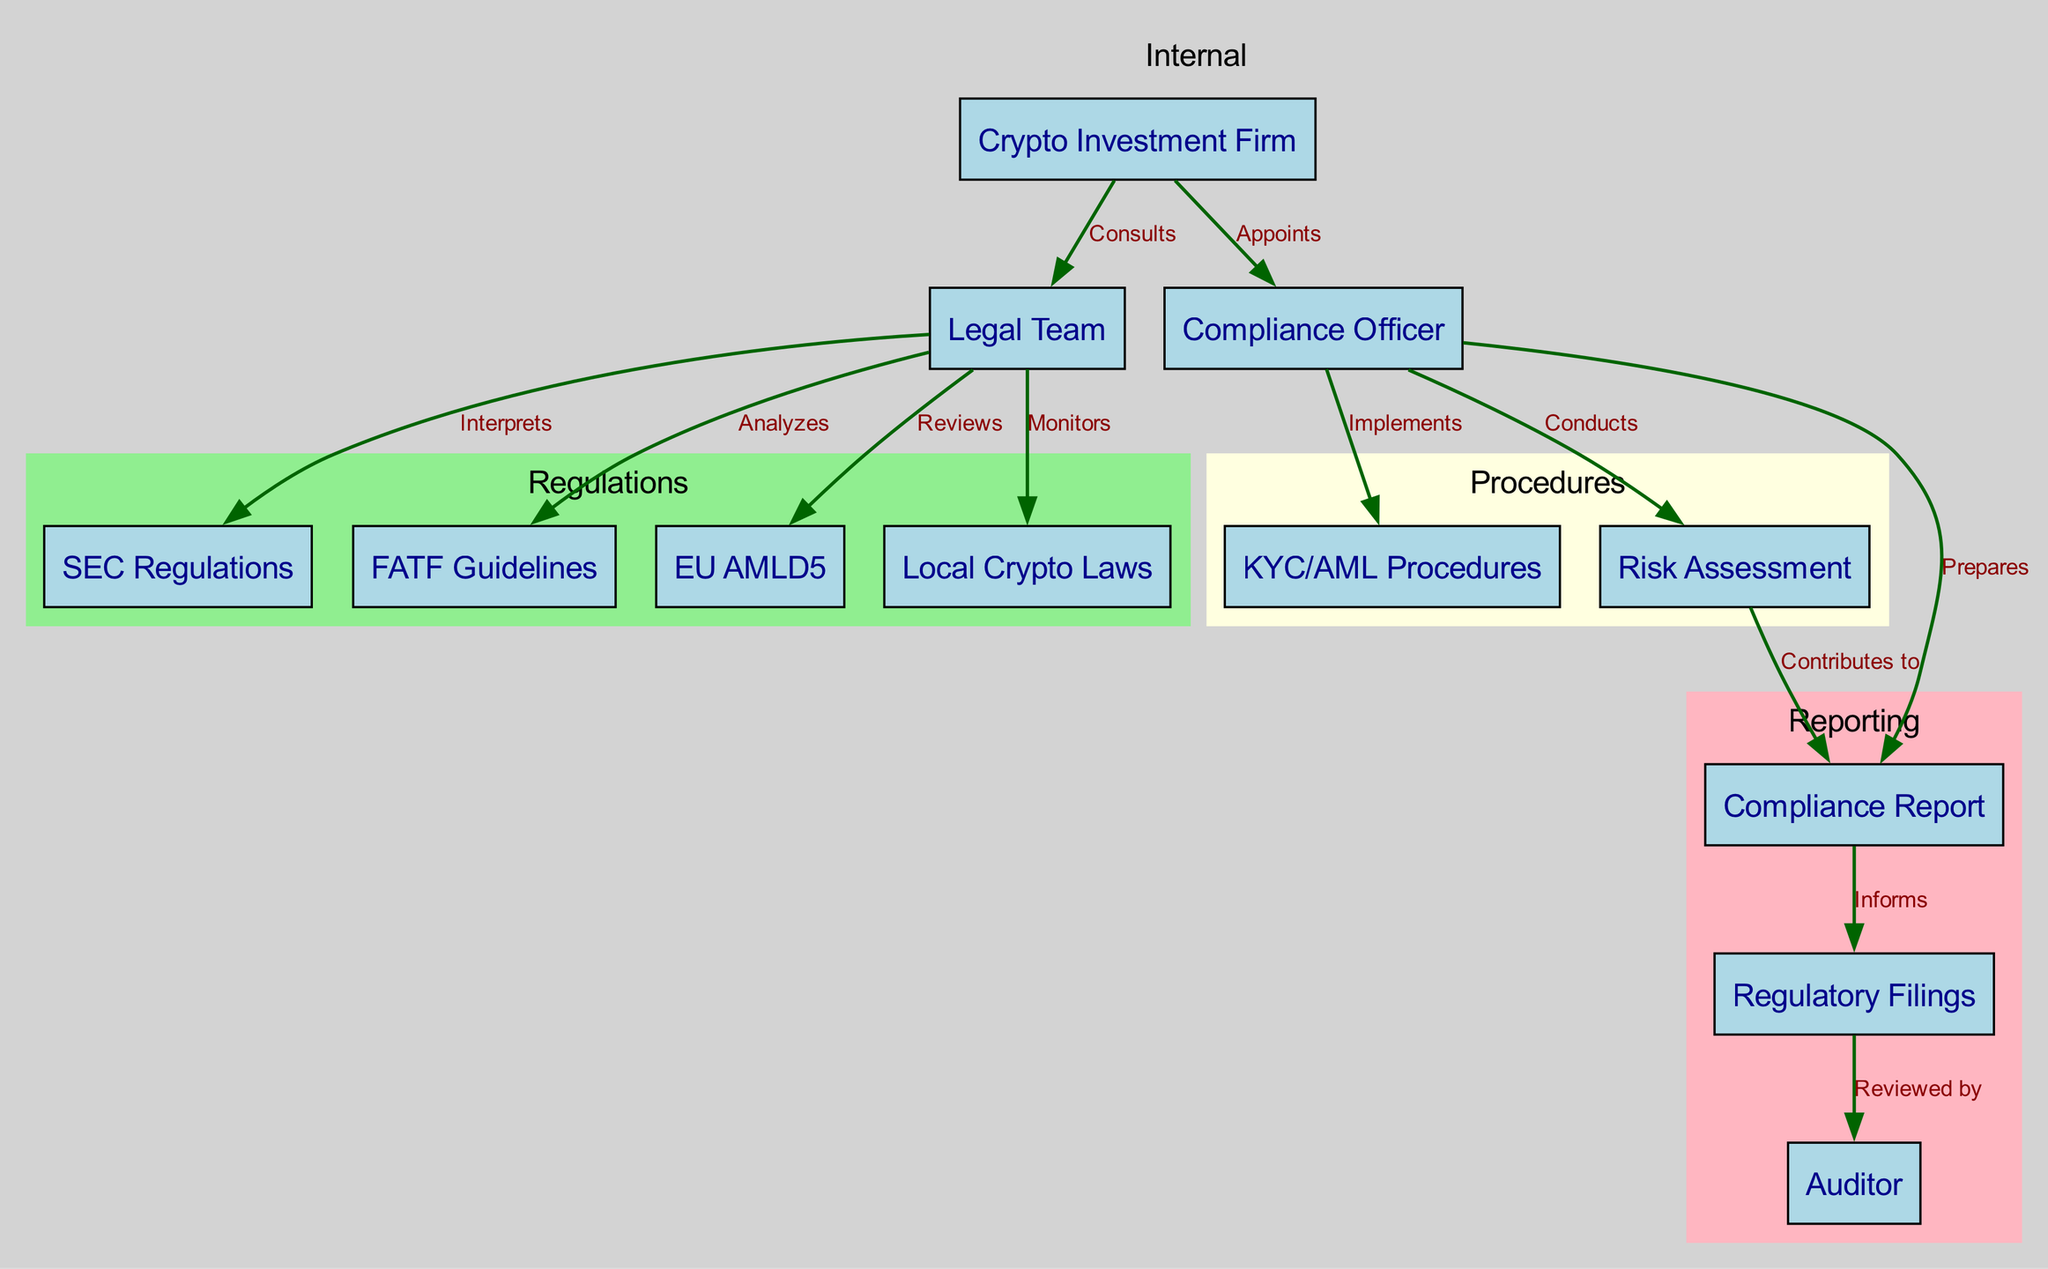What is the total number of nodes in the diagram? The nodes listed in the diagram include: Crypto Investment Firm, Legal Team, Compliance Officer, KYC/AML Procedures, SEC Regulations, FATF Guidelines, EU AMLD5, Local Crypto Laws, Risk Assessment, Compliance Report, Regulatory Filings, and Auditor. Counting these gives a total of 12 nodes.
Answer: 12 Which node is appointed by the Crypto Investment Firm? The edge labeled "Appoints" connects the Crypto Investment Firm to the Compliance Officer, indicating that this position is appointed by the firm.
Answer: Compliance Officer What does the Compliance Officer prepare? The edge labeled "Prepares" connects the Compliance Officer to the Compliance Report, indicating this is the document that they prepare in the compliance process.
Answer: Compliance Report How many procedures are implemented by the Compliance Officer? The diagram shows one procedure that the Compliance Officer implements, which is the KYC/AML Procedures, indicated by the edge labeled "Implements."
Answer: One Which regulations does the Legal Team analyze? The edge labeled "Analyzes" connects the Legal Team to FATF Guidelines. This indicates that among the regulations they analyze, the FATF Guidelines is specifically highlighted.
Answer: FATF Guidelines What contributes to the Compliance Report? The edge labeled "Contributes to" indicates that the Risk Assessment contributes to the Compliance Report, showing a direct relationship where the outcome of the risk assessment informs the report.
Answer: Risk Assessment Who reviews the EU AMLD5? The diagram indicates that the Legal Team reviews the EU AMLD5, as shown by the edge labeled "Reviews." This establishes the responsibility of the Legal Team concerning this regulation.
Answer: Legal Team What is the final entity that reviews the Regulatory Filings? The diagram shows an edge labeled "Reviewed by" that connects the Regulatory Filings to the Auditor. This means the Auditor is the final entity that reviews the filings before they are finalized.
Answer: Auditor Identify the type of procedure that is clustered together with Risk Assessment. In the diagram, the Risk Assessment is clustered with KYC/AML Procedures in the "Procedures" subgraph, indicating they are related forms of compliance procedures.
Answer: KYC/AML Procedures 